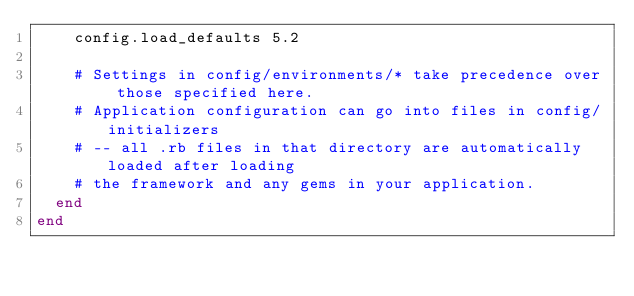<code> <loc_0><loc_0><loc_500><loc_500><_Ruby_>    config.load_defaults 5.2

    # Settings in config/environments/* take precedence over those specified here.
    # Application configuration can go into files in config/initializers
    # -- all .rb files in that directory are automatically loaded after loading
    # the framework and any gems in your application.
  end
end
</code> 